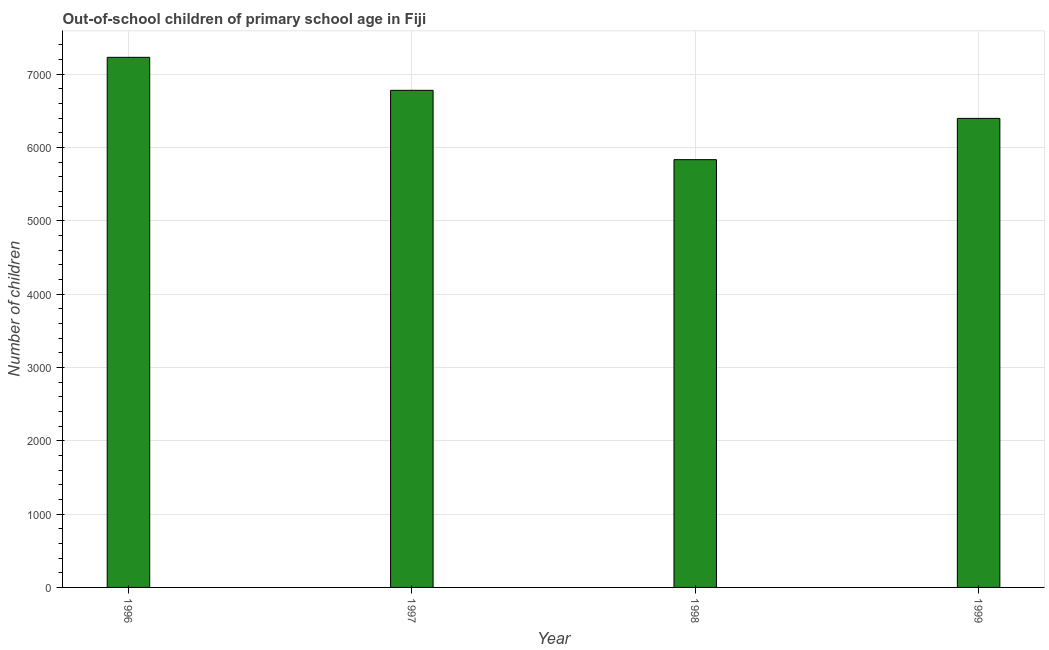Does the graph contain grids?
Ensure brevity in your answer.  Yes. What is the title of the graph?
Your answer should be very brief. Out-of-school children of primary school age in Fiji. What is the label or title of the Y-axis?
Provide a short and direct response. Number of children. What is the number of out-of-school children in 1997?
Your answer should be very brief. 6781. Across all years, what is the maximum number of out-of-school children?
Your response must be concise. 7231. Across all years, what is the minimum number of out-of-school children?
Give a very brief answer. 5835. In which year was the number of out-of-school children maximum?
Your response must be concise. 1996. What is the sum of the number of out-of-school children?
Ensure brevity in your answer.  2.62e+04. What is the difference between the number of out-of-school children in 1998 and 1999?
Your answer should be compact. -563. What is the average number of out-of-school children per year?
Provide a short and direct response. 6561. What is the median number of out-of-school children?
Offer a very short reply. 6589.5. In how many years, is the number of out-of-school children greater than 5200 ?
Ensure brevity in your answer.  4. What is the ratio of the number of out-of-school children in 1998 to that in 1999?
Your response must be concise. 0.91. Is the number of out-of-school children in 1998 less than that in 1999?
Offer a very short reply. Yes. What is the difference between the highest and the second highest number of out-of-school children?
Your answer should be very brief. 450. What is the difference between the highest and the lowest number of out-of-school children?
Keep it short and to the point. 1396. In how many years, is the number of out-of-school children greater than the average number of out-of-school children taken over all years?
Provide a short and direct response. 2. Are all the bars in the graph horizontal?
Provide a short and direct response. No. How many years are there in the graph?
Your response must be concise. 4. What is the Number of children of 1996?
Give a very brief answer. 7231. What is the Number of children of 1997?
Your answer should be very brief. 6781. What is the Number of children of 1998?
Offer a terse response. 5835. What is the Number of children of 1999?
Your answer should be compact. 6398. What is the difference between the Number of children in 1996 and 1997?
Your answer should be compact. 450. What is the difference between the Number of children in 1996 and 1998?
Your response must be concise. 1396. What is the difference between the Number of children in 1996 and 1999?
Your response must be concise. 833. What is the difference between the Number of children in 1997 and 1998?
Ensure brevity in your answer.  946. What is the difference between the Number of children in 1997 and 1999?
Make the answer very short. 383. What is the difference between the Number of children in 1998 and 1999?
Provide a succinct answer. -563. What is the ratio of the Number of children in 1996 to that in 1997?
Provide a short and direct response. 1.07. What is the ratio of the Number of children in 1996 to that in 1998?
Offer a very short reply. 1.24. What is the ratio of the Number of children in 1996 to that in 1999?
Keep it short and to the point. 1.13. What is the ratio of the Number of children in 1997 to that in 1998?
Make the answer very short. 1.16. What is the ratio of the Number of children in 1997 to that in 1999?
Offer a very short reply. 1.06. What is the ratio of the Number of children in 1998 to that in 1999?
Make the answer very short. 0.91. 